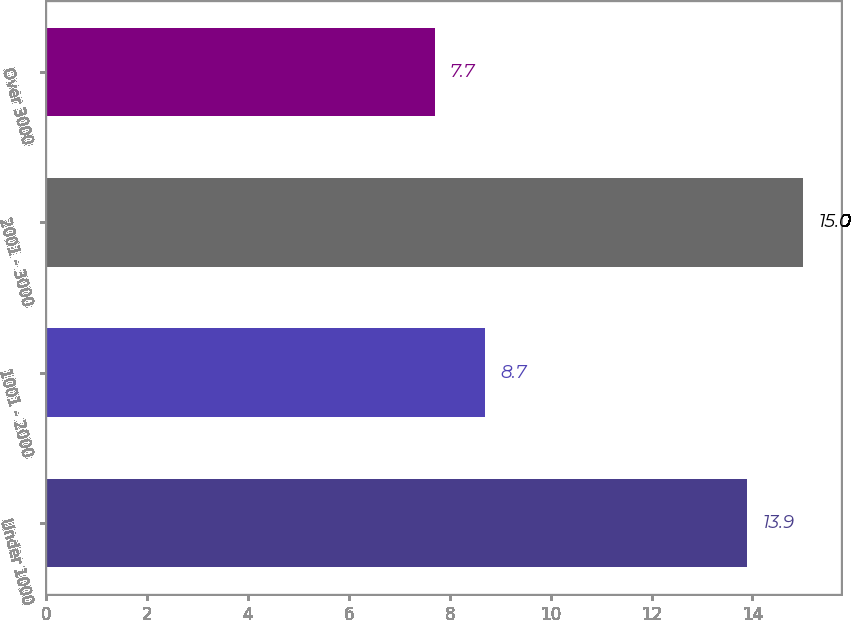<chart> <loc_0><loc_0><loc_500><loc_500><bar_chart><fcel>Under 1000<fcel>1001 - 2000<fcel>2001 - 3000<fcel>Over 3000<nl><fcel>13.9<fcel>8.7<fcel>15<fcel>7.7<nl></chart> 